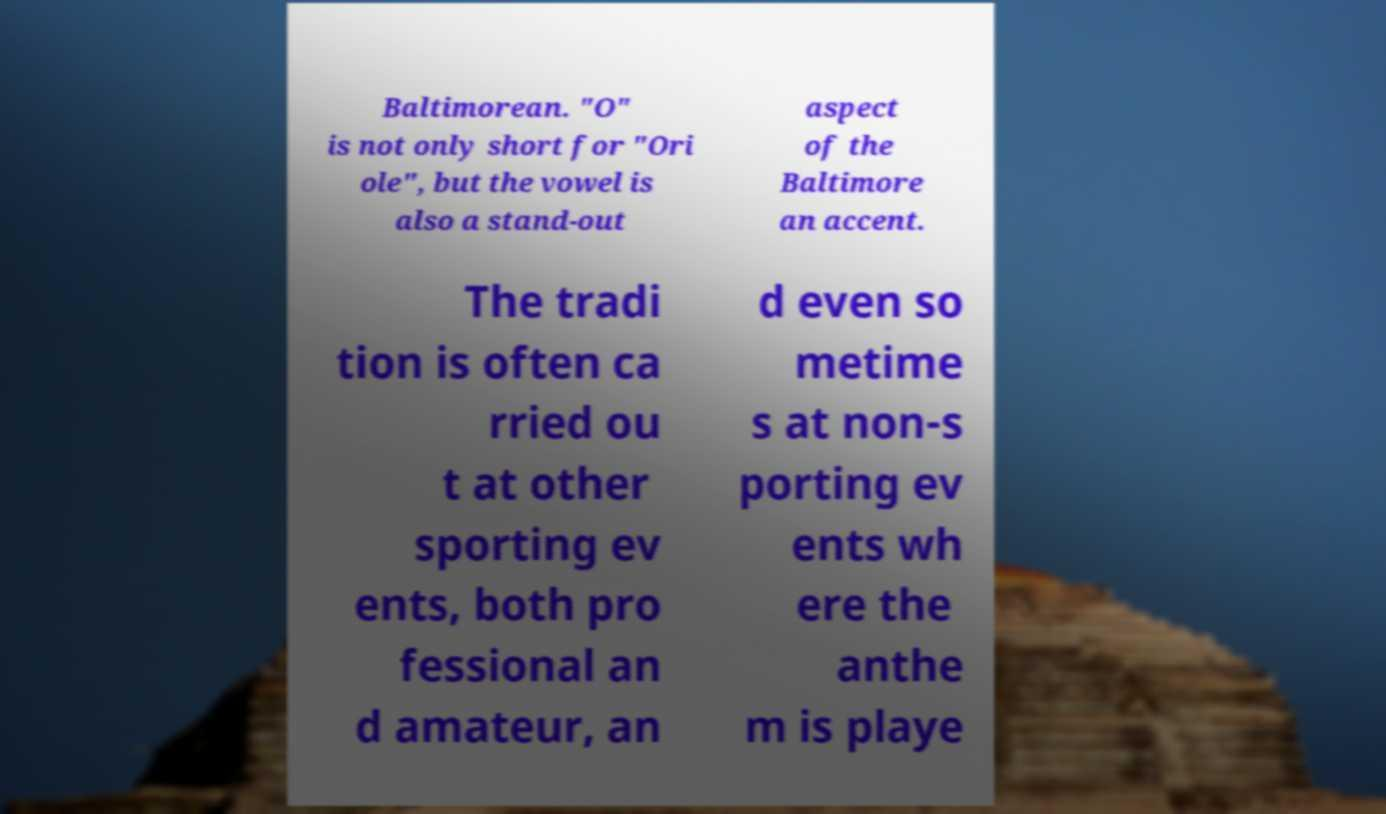Please identify and transcribe the text found in this image. Baltimorean. "O" is not only short for "Ori ole", but the vowel is also a stand-out aspect of the Baltimore an accent. The tradi tion is often ca rried ou t at other sporting ev ents, both pro fessional an d amateur, an d even so metime s at non-s porting ev ents wh ere the anthe m is playe 